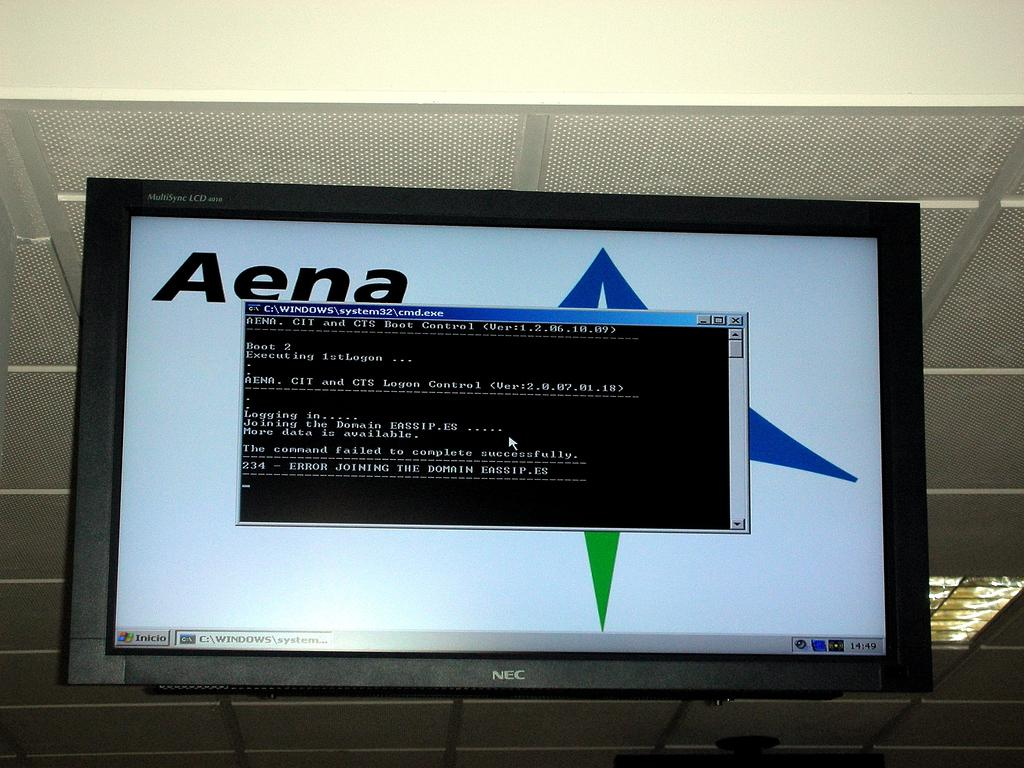Provide a one-sentence caption for the provided image. An NEC television monitor is displaying an error and. 